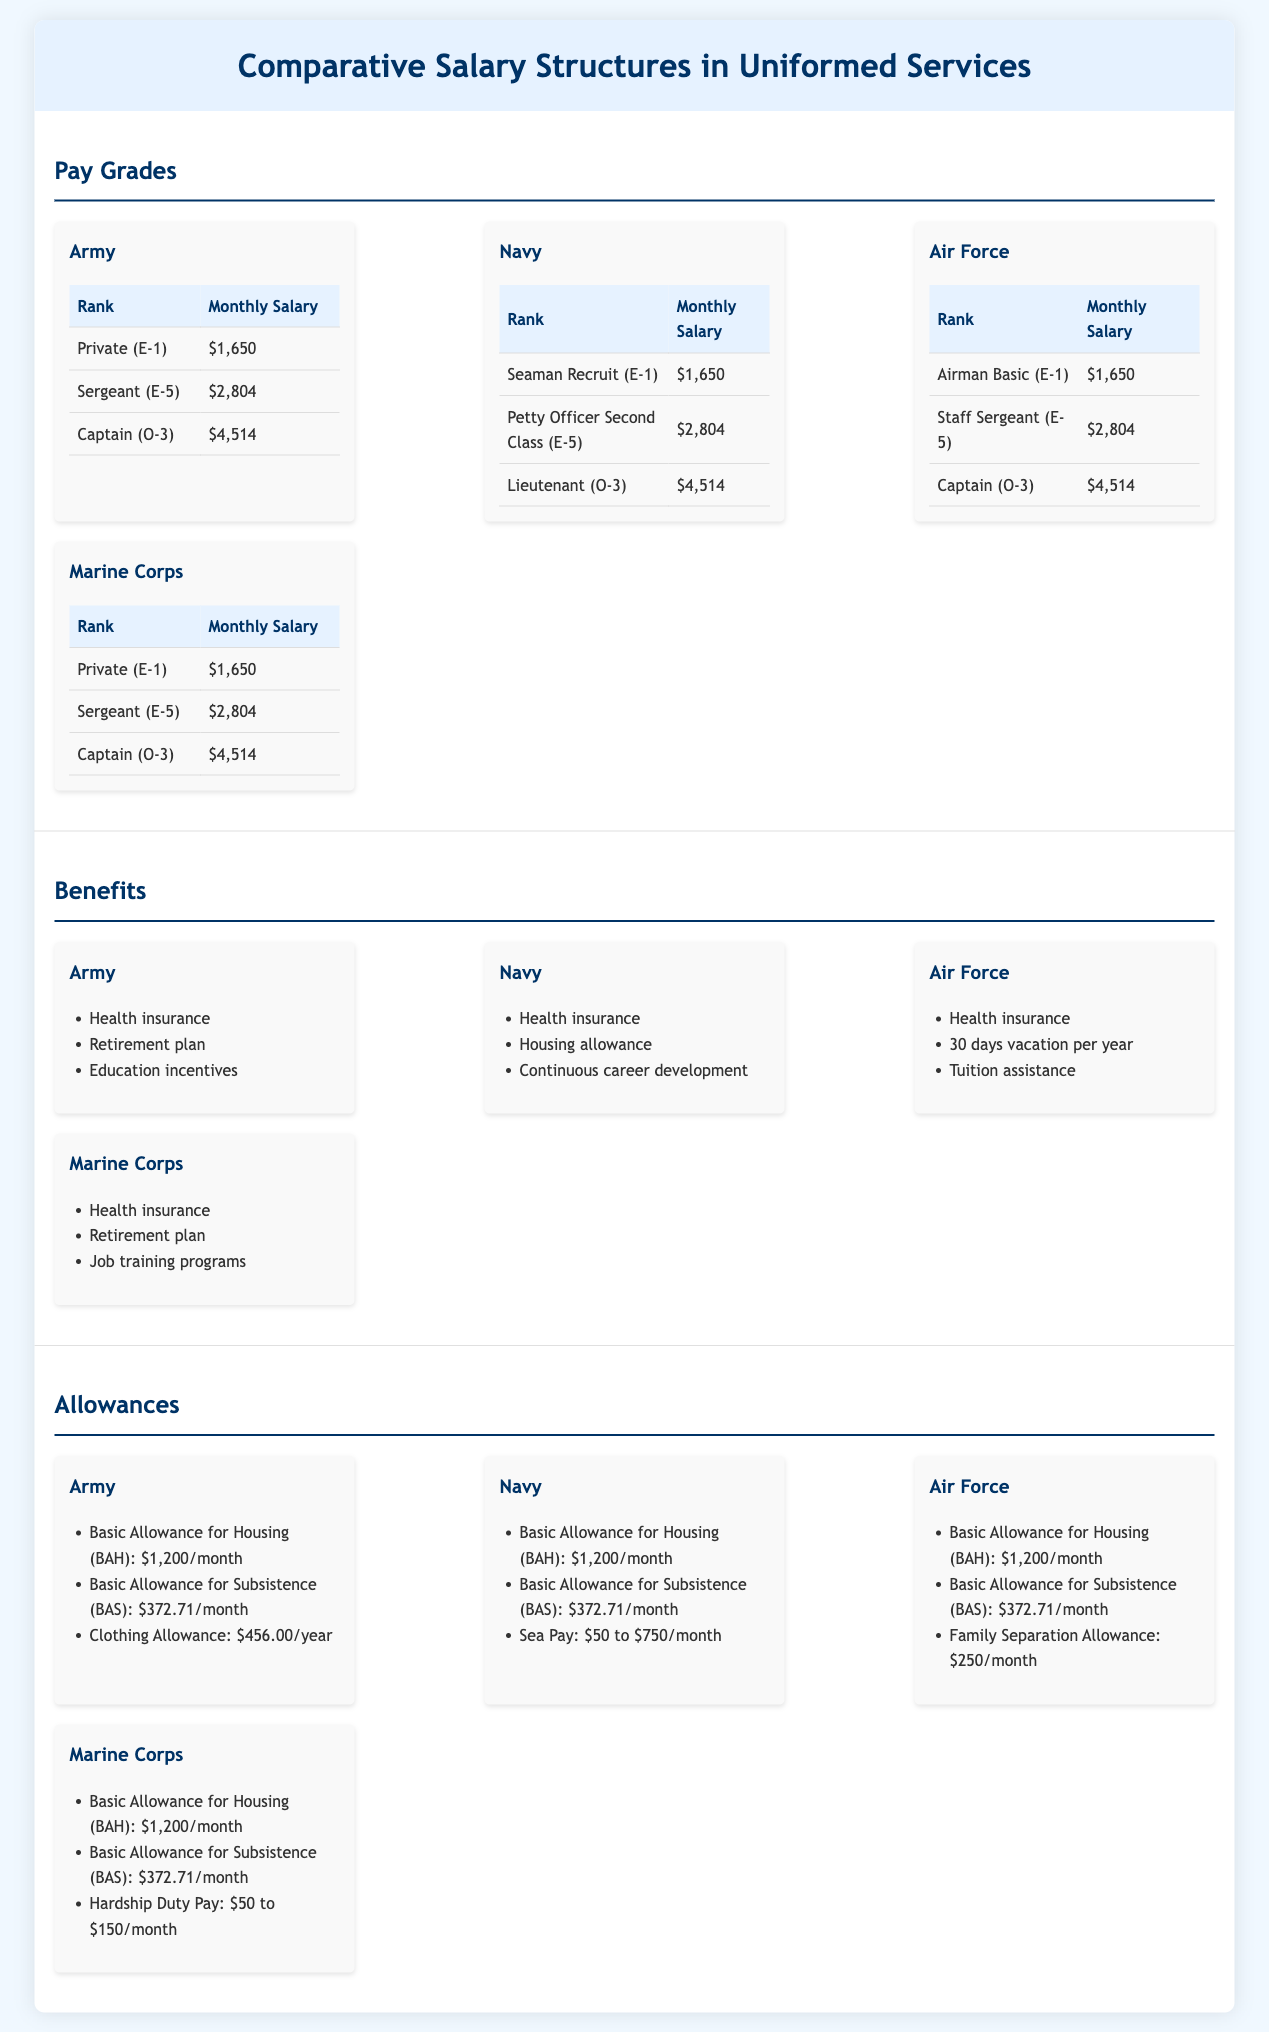What is the monthly salary for a Private (E-1) in the Army? The monthly salary for a Private (E-1) in the Army is specified in the document.
Answer: $1,650 What benefits are available to Navy personnel? The document lists various benefits specific to the Navy, which include health insurance, housing allowance, and continuous career development.
Answer: Health insurance, housing allowance, continuous career development What is the Basic Allowance for Housing (BAH) for the Air Force? The document provides the amount for the Basic Allowance for Housing for each branch, indicating a consistent value across branches.
Answer: $1,200/month Which rank in the Marine Corps earns a salary of $2,804? The document states the monthly salary figures for the Marine Corps ranks, allowing for easy identification of the corresponding rank.
Answer: Sergeant (E-5) What is the Family Separation Allowance for the Air Force? The specific amount for the Family Separation Allowance is mentioned in the allowances section of the Air Force.
Answer: $250/month How many days of vacation per year do Air Force members receive? The document lists vacation benefits specific to the Air Force, providing clarity on the number of vacation days allotted.
Answer: 30 days Which branch has "Job training programs" listed as a benefit? The benefits section of the document includes a list of benefits by branch, highlighting unique offerings for each.
Answer: Marine Corps What is the highest monthly salary listed for any rank across the branches? The document allows for a comparative understanding of salary structures for different ranks across branches to identify the highest salary.
Answer: $4,514 What type of pay can Navy members receive that varies by amount? The document specifies types of allowances that can vary, focusing on the Navy's sea pay.
Answer: Sea Pay 